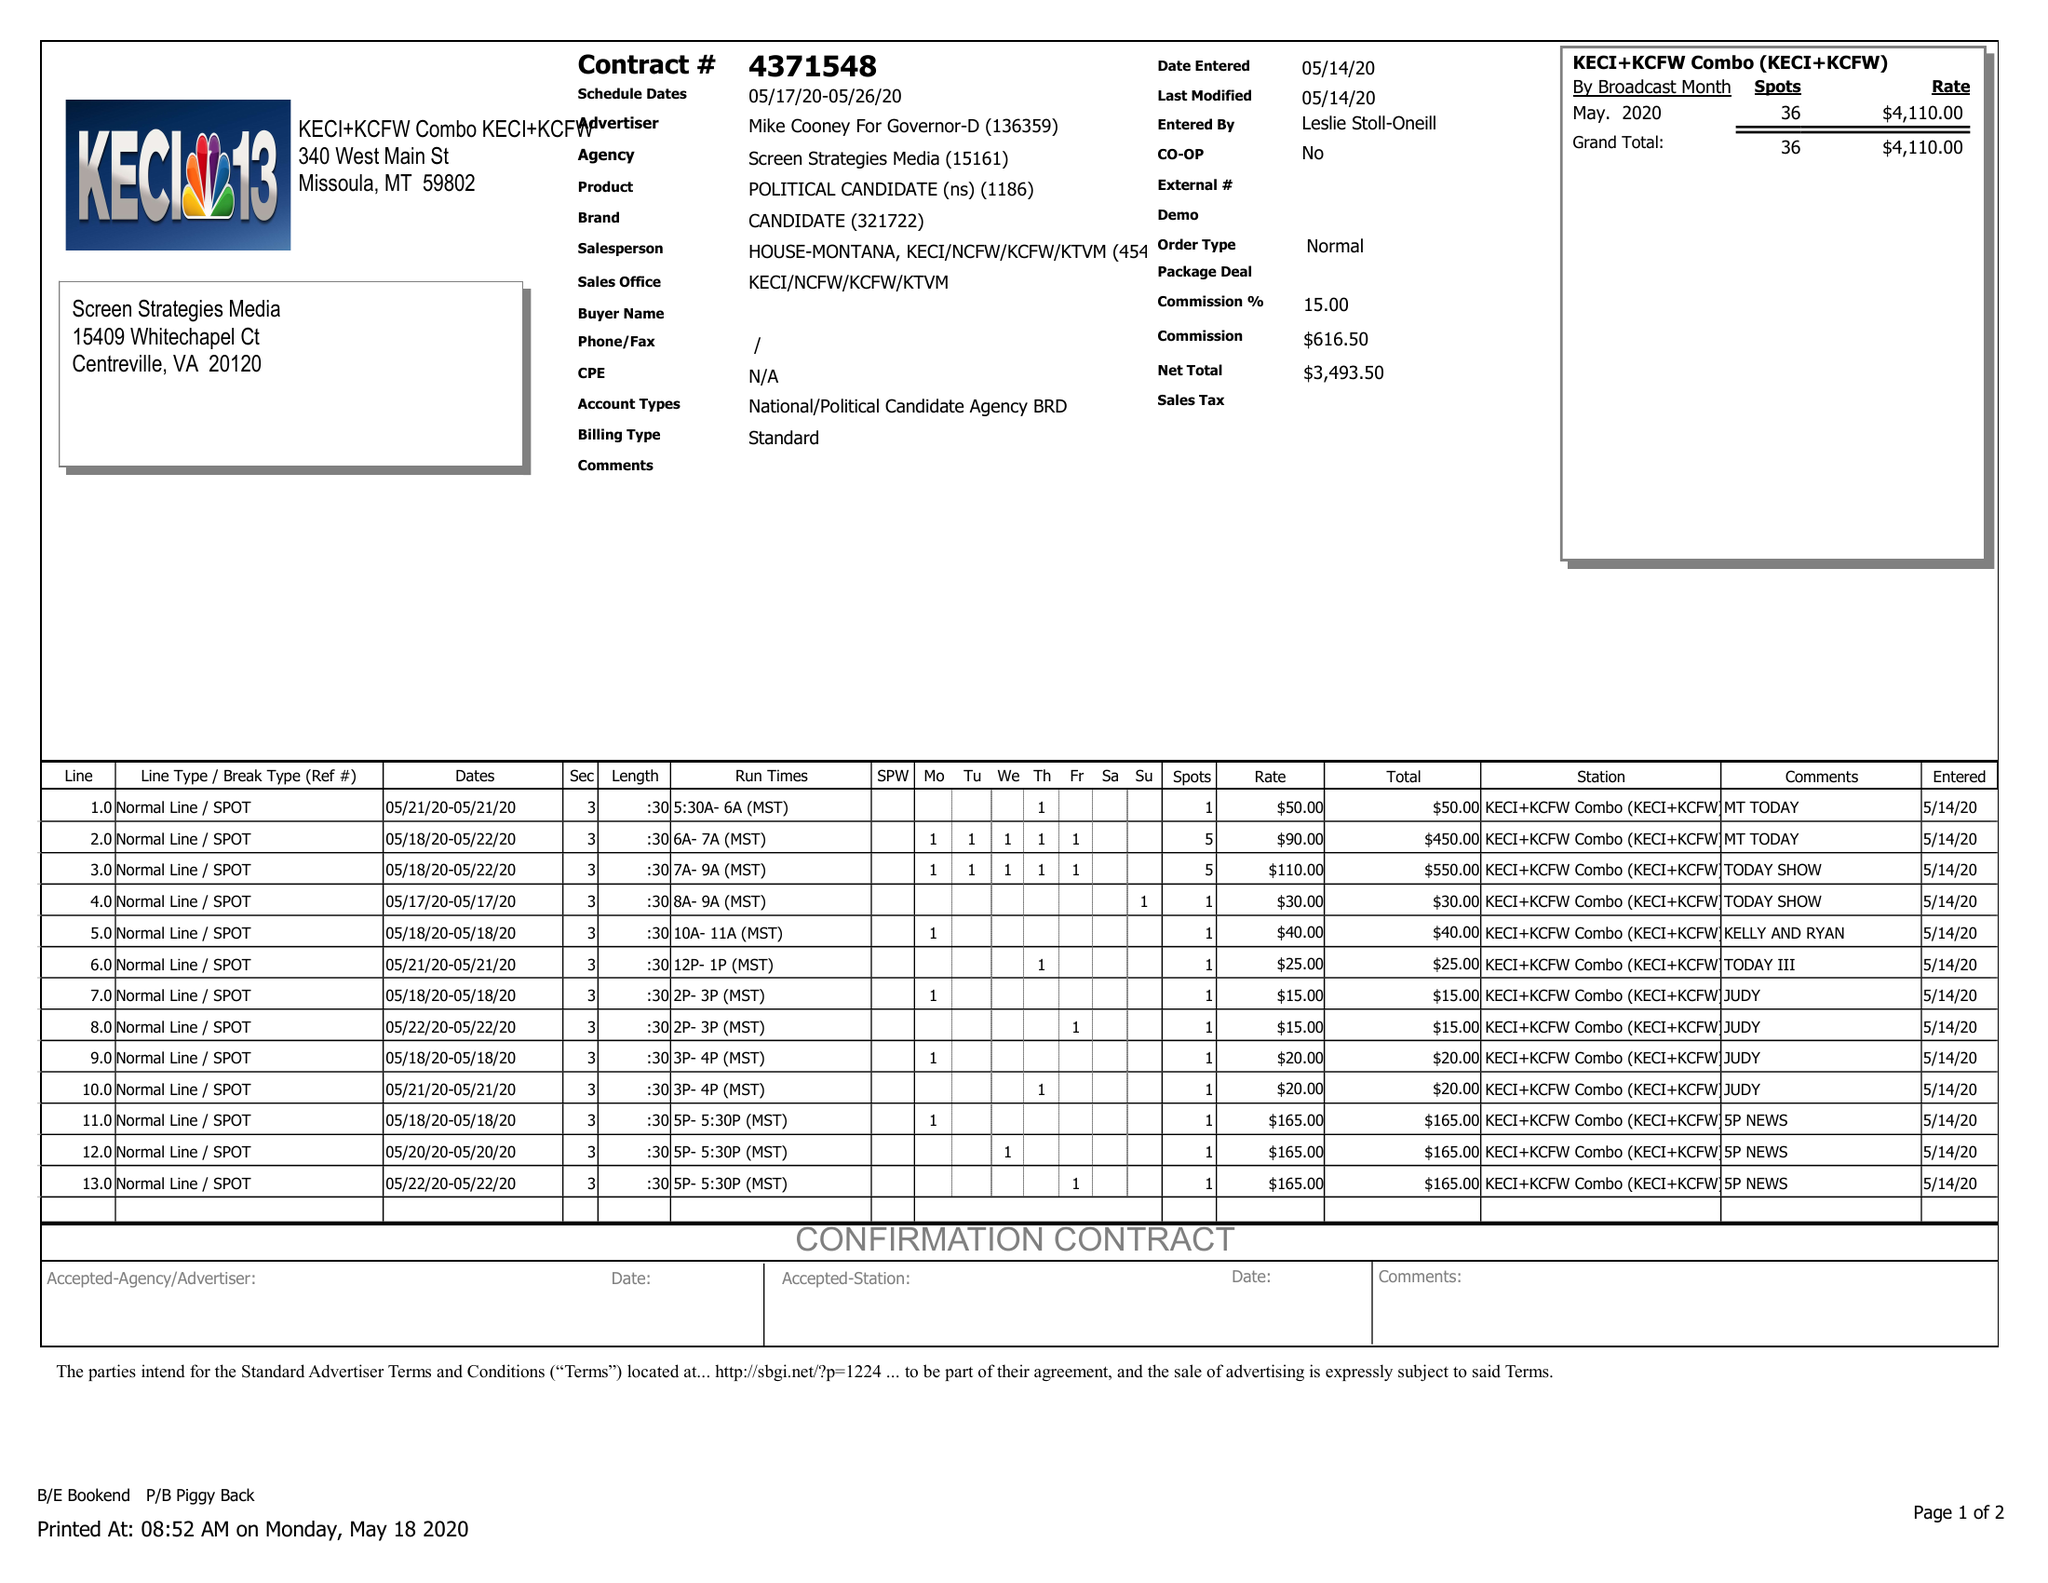What is the value for the gross_amount?
Answer the question using a single word or phrase. 4110.00 